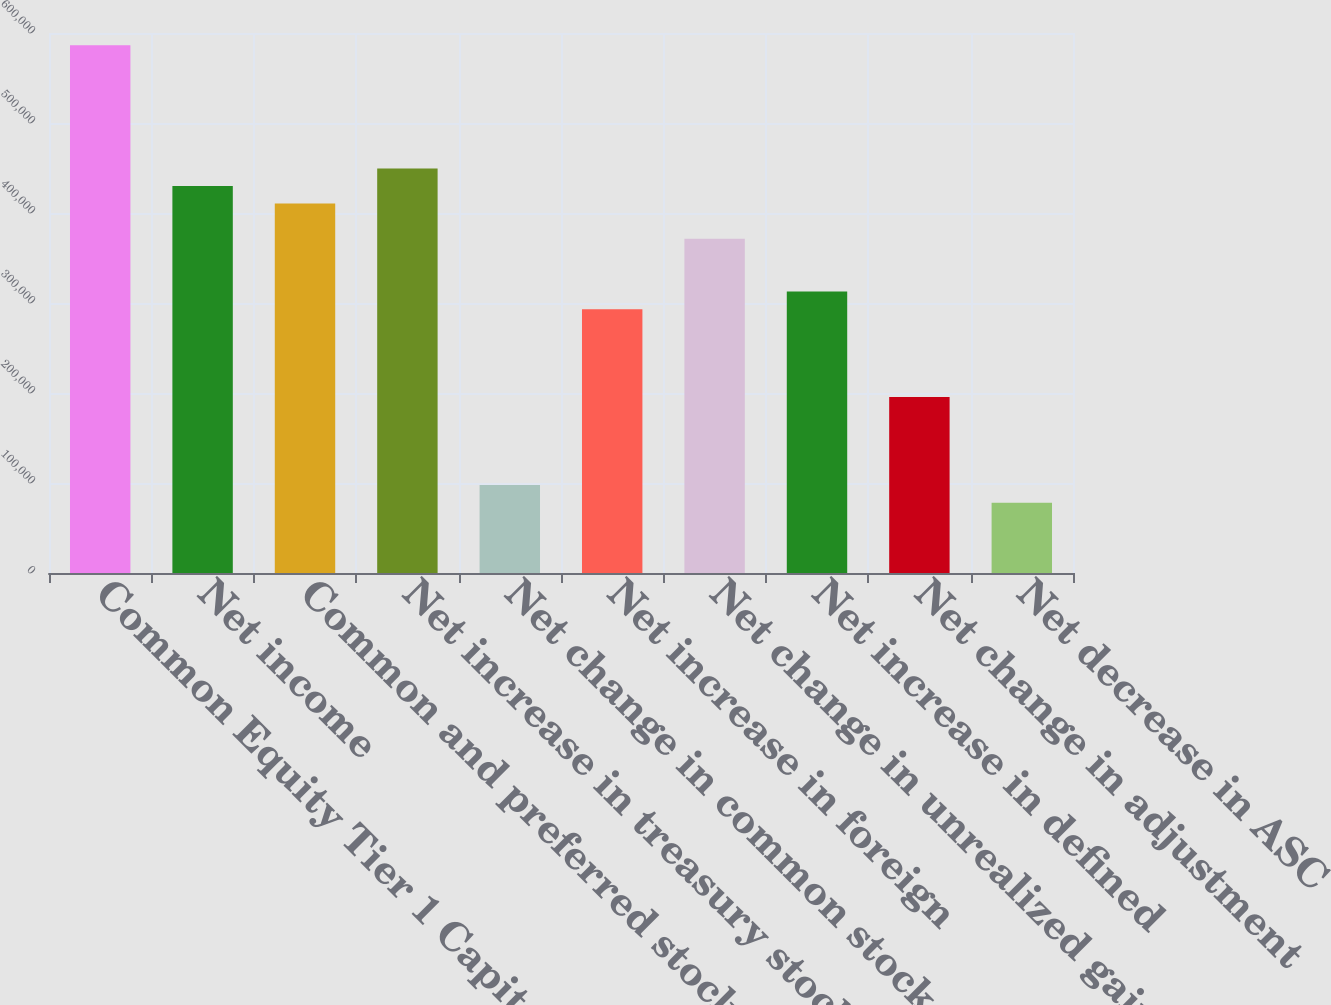Convert chart. <chart><loc_0><loc_0><loc_500><loc_500><bar_chart><fcel>Common Equity Tier 1 Capital<fcel>Net income<fcel>Common and preferred stock<fcel>Net increase in treasury stock<fcel>Net change in common stock and<fcel>Net increase in foreign<fcel>Net change in unrealized gains<fcel>Net increase in defined<fcel>Net change in adjustment<fcel>Net decrease in ASC<nl><fcel>586318<fcel>429967<fcel>410423<fcel>449511<fcel>97720.5<fcel>293160<fcel>371335<fcel>312703<fcel>195440<fcel>78176.6<nl></chart> 